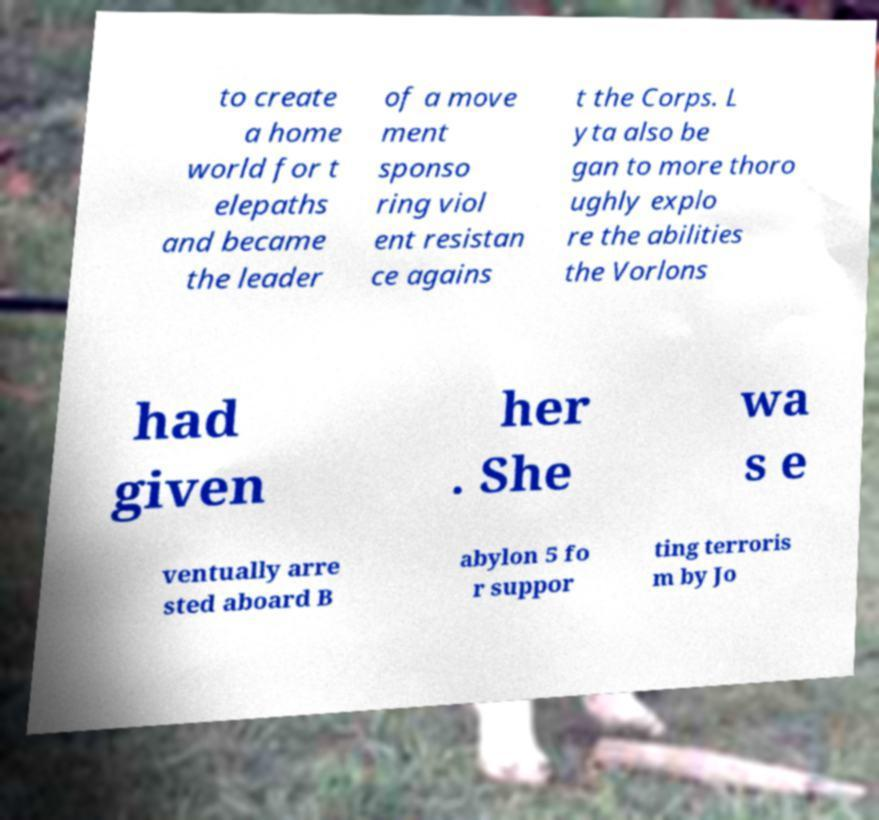Could you extract and type out the text from this image? to create a home world for t elepaths and became the leader of a move ment sponso ring viol ent resistan ce agains t the Corps. L yta also be gan to more thoro ughly explo re the abilities the Vorlons had given her . She wa s e ventually arre sted aboard B abylon 5 fo r suppor ting terroris m by Jo 